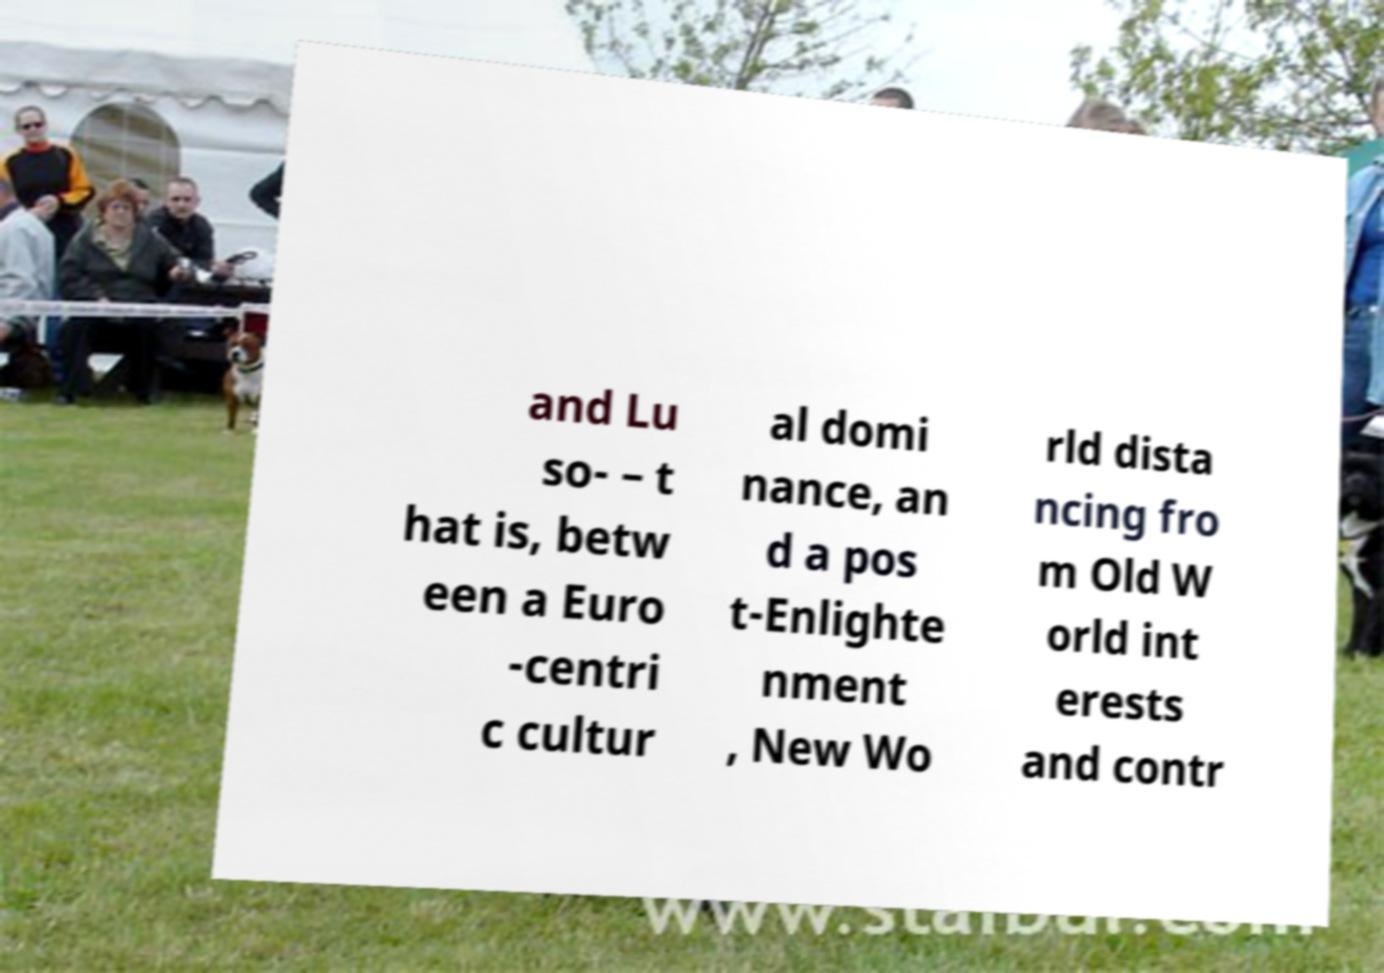Please read and relay the text visible in this image. What does it say? and Lu so- – t hat is, betw een a Euro -centri c cultur al domi nance, an d a pos t-Enlighte nment , New Wo rld dista ncing fro m Old W orld int erests and contr 